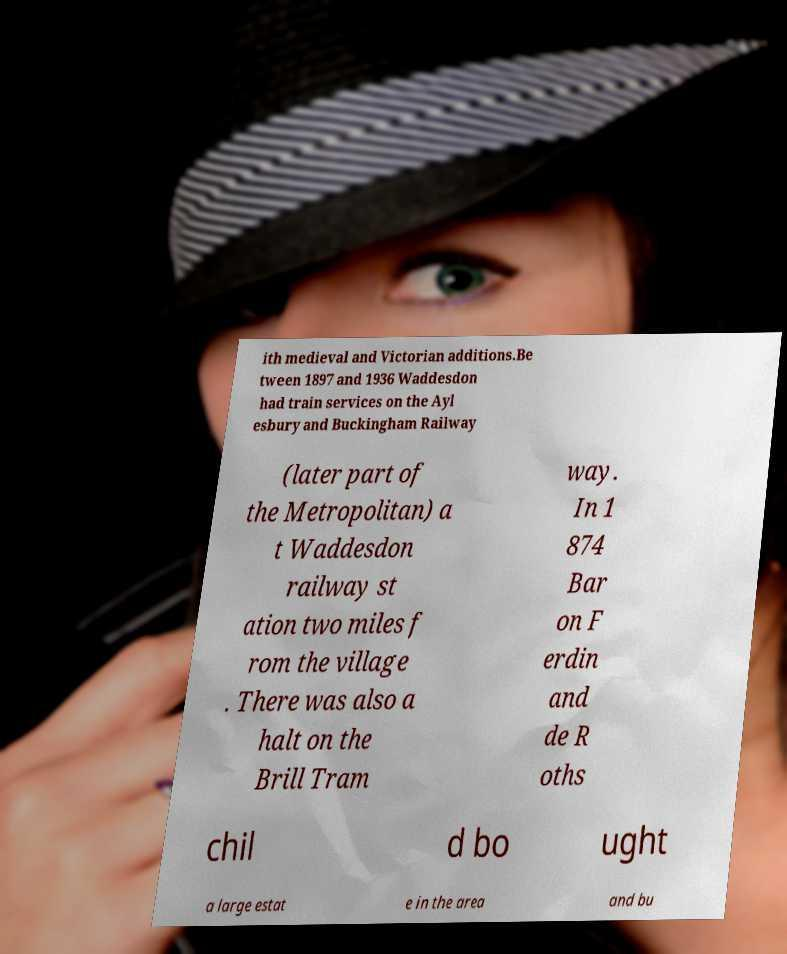There's text embedded in this image that I need extracted. Can you transcribe it verbatim? ith medieval and Victorian additions.Be tween 1897 and 1936 Waddesdon had train services on the Ayl esbury and Buckingham Railway (later part of the Metropolitan) a t Waddesdon railway st ation two miles f rom the village . There was also a halt on the Brill Tram way. In 1 874 Bar on F erdin and de R oths chil d bo ught a large estat e in the area and bu 